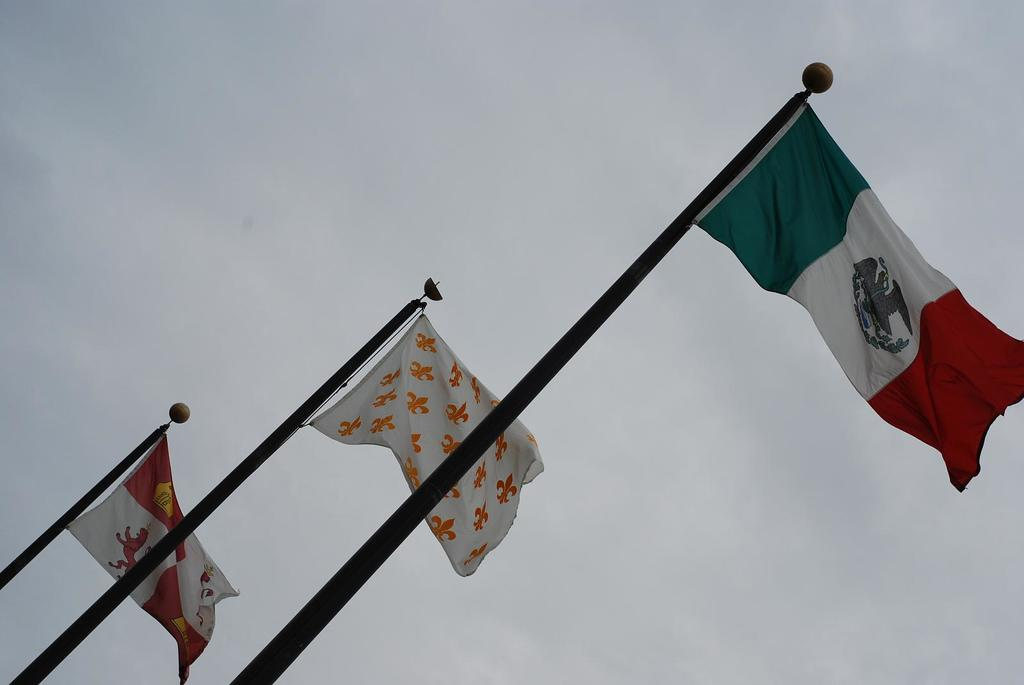How many flag poles are present in the image? There are three flag poles in the image. How many flags are attached to the flag poles? There are three flags in the image. What colors can be seen on the flags? The flags have colors: white, red, orange, and green. What is visible in the background of the image? The sky is visible in the background of the image. How many sisters can be seen playing on the hill in the image? There are no sisters or hills present in the image; it features three flag poles with flags and a visible sky. 